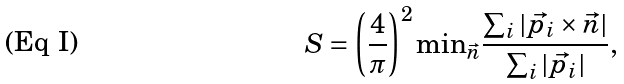Convert formula to latex. <formula><loc_0><loc_0><loc_500><loc_500>S = \left ( \frac { 4 } { \pi } \right ) ^ { 2 } { \min } _ { \vec { n } } \frac { \sum _ { i } | \vec { p _ { i } } \times \vec { n } | } { \sum _ { i } | \vec { p _ { i } } | } ,</formula> 